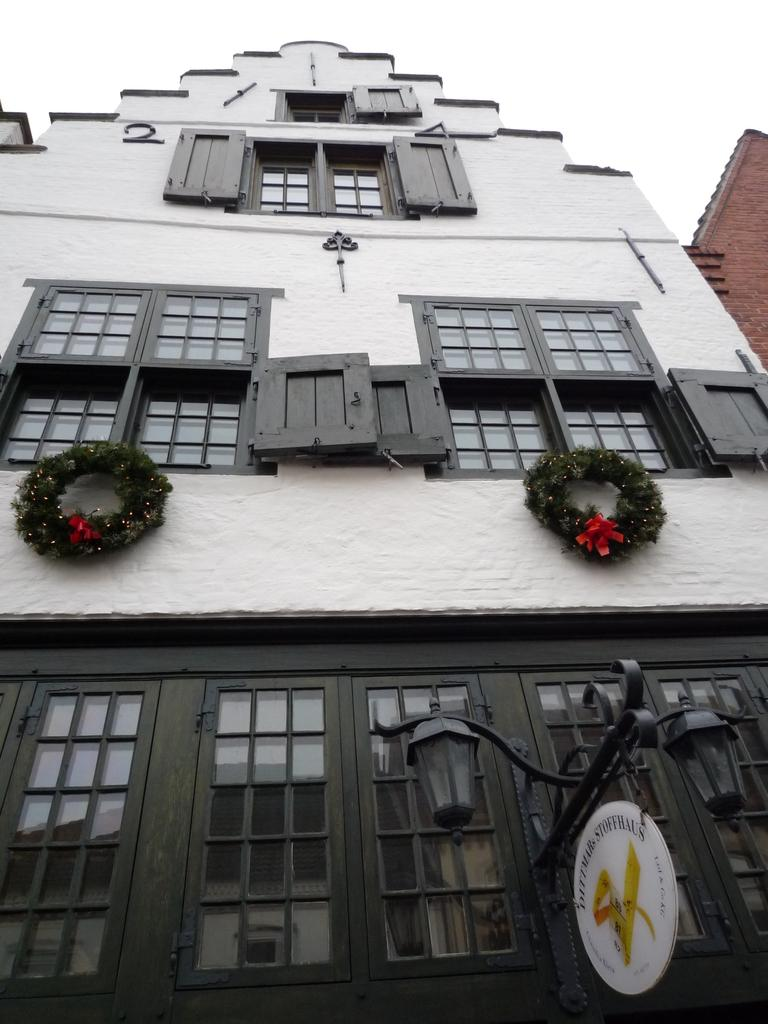What type of structures are present in the image? There are buildings in the image. What feature can be seen on the buildings? There are windows in the buildings. What other object is visible in the image? There is a light pole in the image. What is visible at the top of the image? The sky is visible at the top of the image. Can you tell me the name of the creator of the light pole in the image? There is no information about the creator of the light pole in the image. What type of loaf is being sold in the buildings in the image? There is no indication of any loaf being sold or present in the image. 